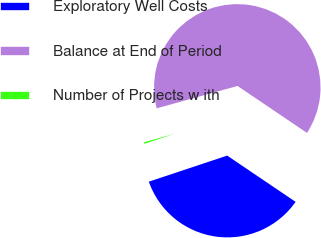Convert chart. <chart><loc_0><loc_0><loc_500><loc_500><pie_chart><fcel>Exploratory Well Costs<fcel>Balance at End of Period<fcel>Number of Projects w ith<nl><fcel>35.42%<fcel>63.75%<fcel>0.82%<nl></chart> 